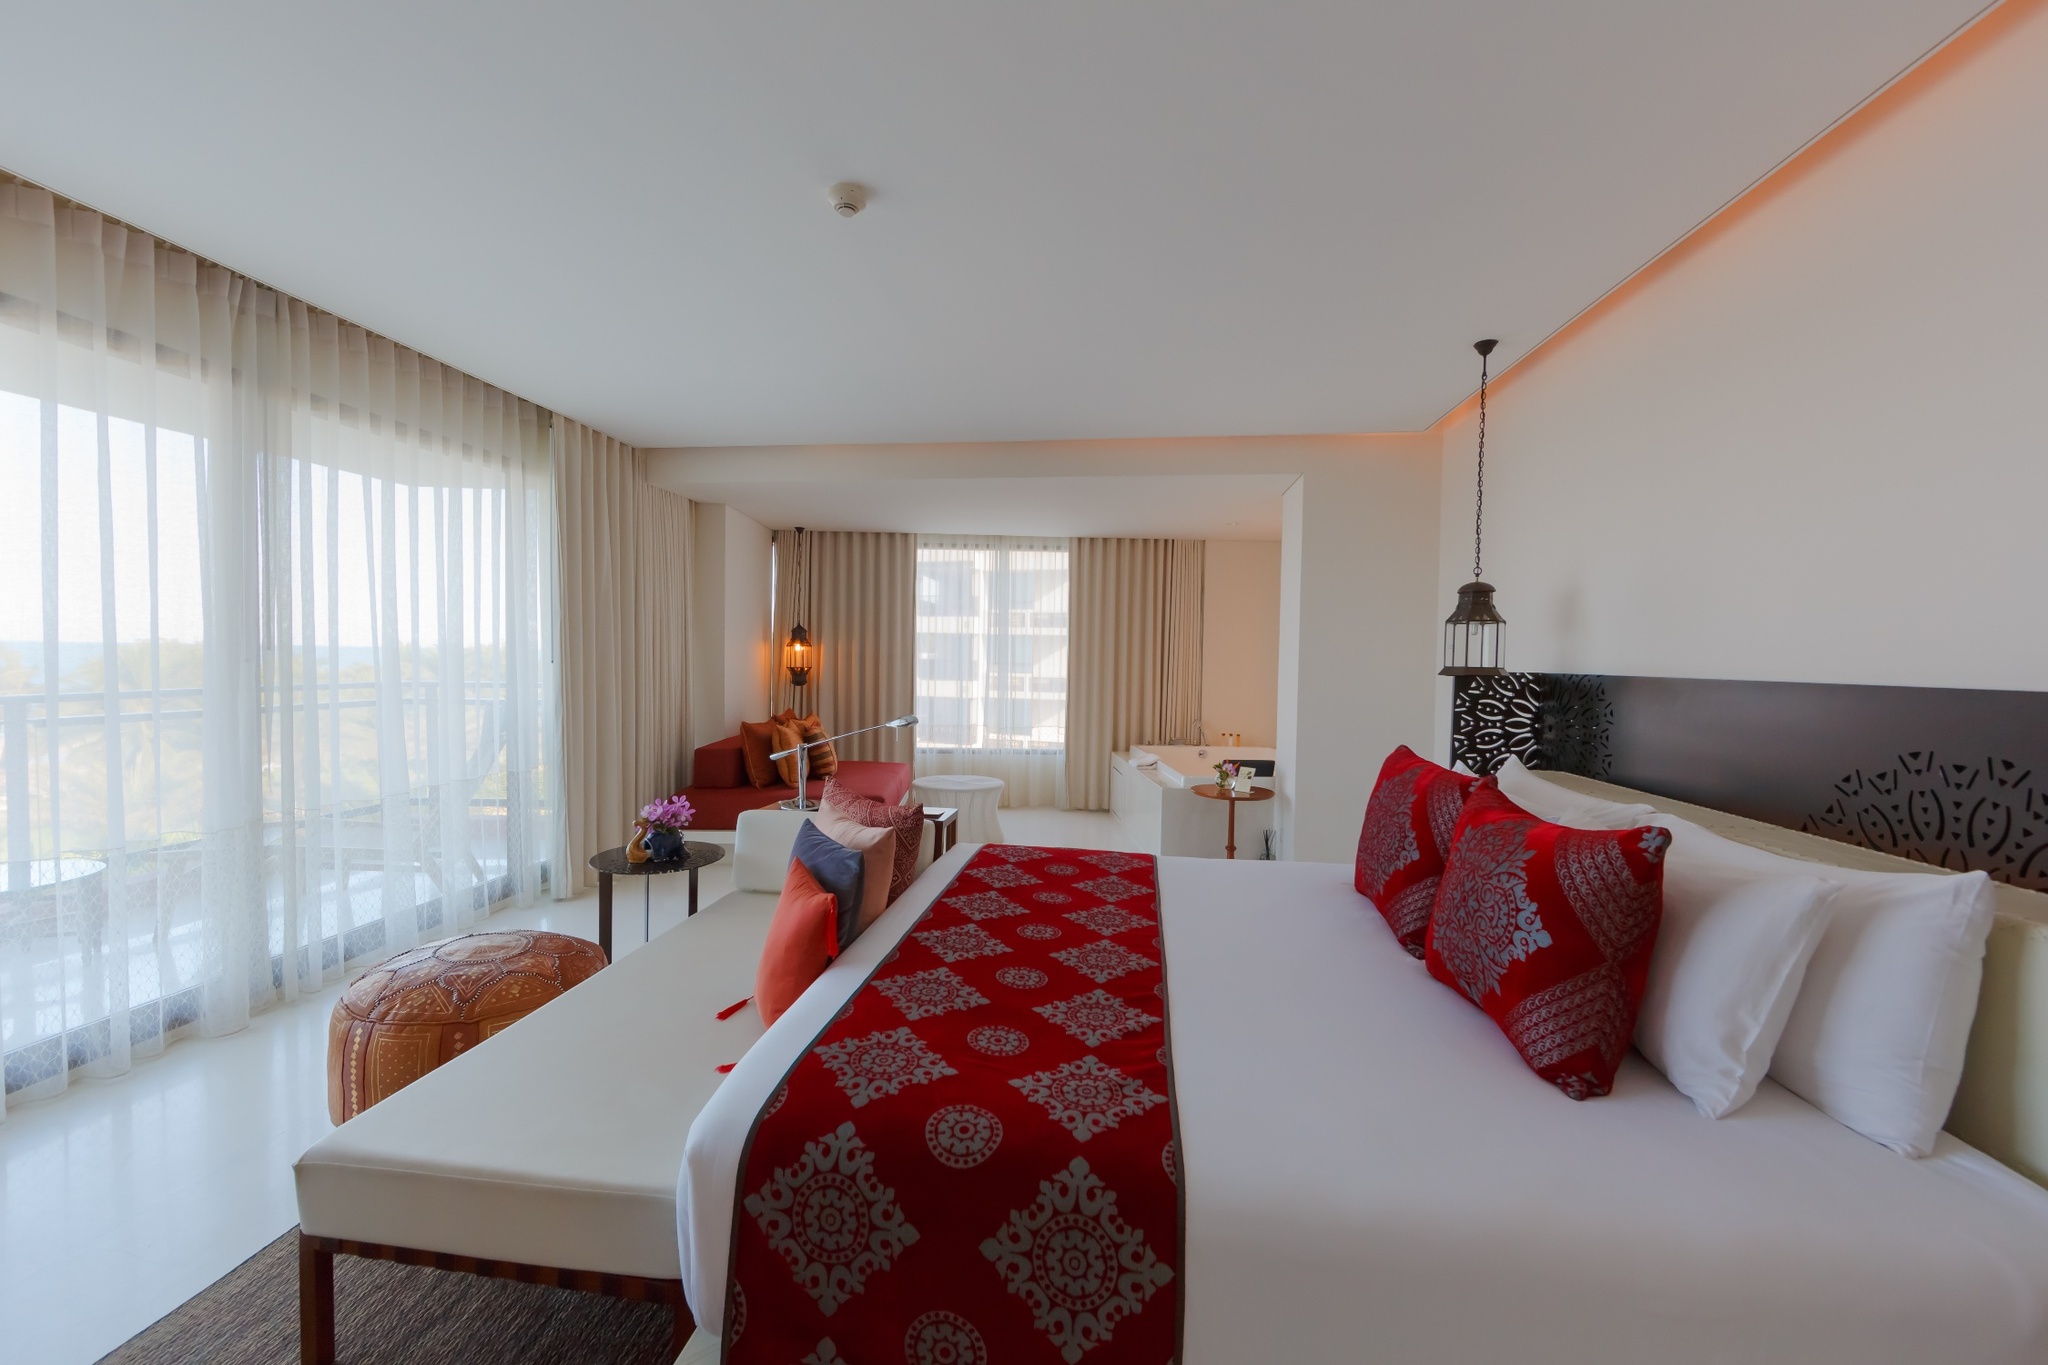Analyze the image in a comprehensive and detailed manner. The image showcases a luxurious and spacious hotel room, bathed in abundant natural light from large windows that stretch across the walls. These windows are adorned with sheer white curtains and open up to reveal a scenic balcony with panoramic views of the surrounding landscape.

The focal point of the room is a large, neatly made white bed, which is accentuated by vibrant red and white pillows and a matching red bed runner with intricate patterns. Situated beside the bed is a wooden side table that holds a vase brimming with colorful flowers, bringing a touch of nature indoors.

To the right of the room stands a sleek wooden desk, accompanied by a lamp and a modern chair, suggesting a dedicated workspace. This workspace is strategically placed near the windows to harness natural light during the day.

Additional seating is provided by a plush seating area adjacent to the windows, which includes a cozy sofa adorned with orange and beige throw pillows and a small round table. The overall room design incorporates a blend of modern and traditional elements, with white walls and ceiling complemented by a warm wooden floor.

This tranquil and inviting setting, devoid of any motion or text, has objects arranged thoughtfully for both comfort and functionality. The bed's central placement, the side table within easy reach, and the desk near natural light all emphasize a well-designed layout that caters to relaxation, rest, and productivity. In summary, the image presents a serene and luxurious hotel room that perfectly balances comfort and practicality, making it ideal for guests seeking relaxation and a little bit of work. 